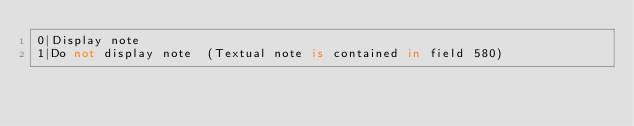Convert code to text. <code><loc_0><loc_0><loc_500><loc_500><_SQL_>0|Display note
1|Do not display note  (Textual note is contained in field 580)







</code> 